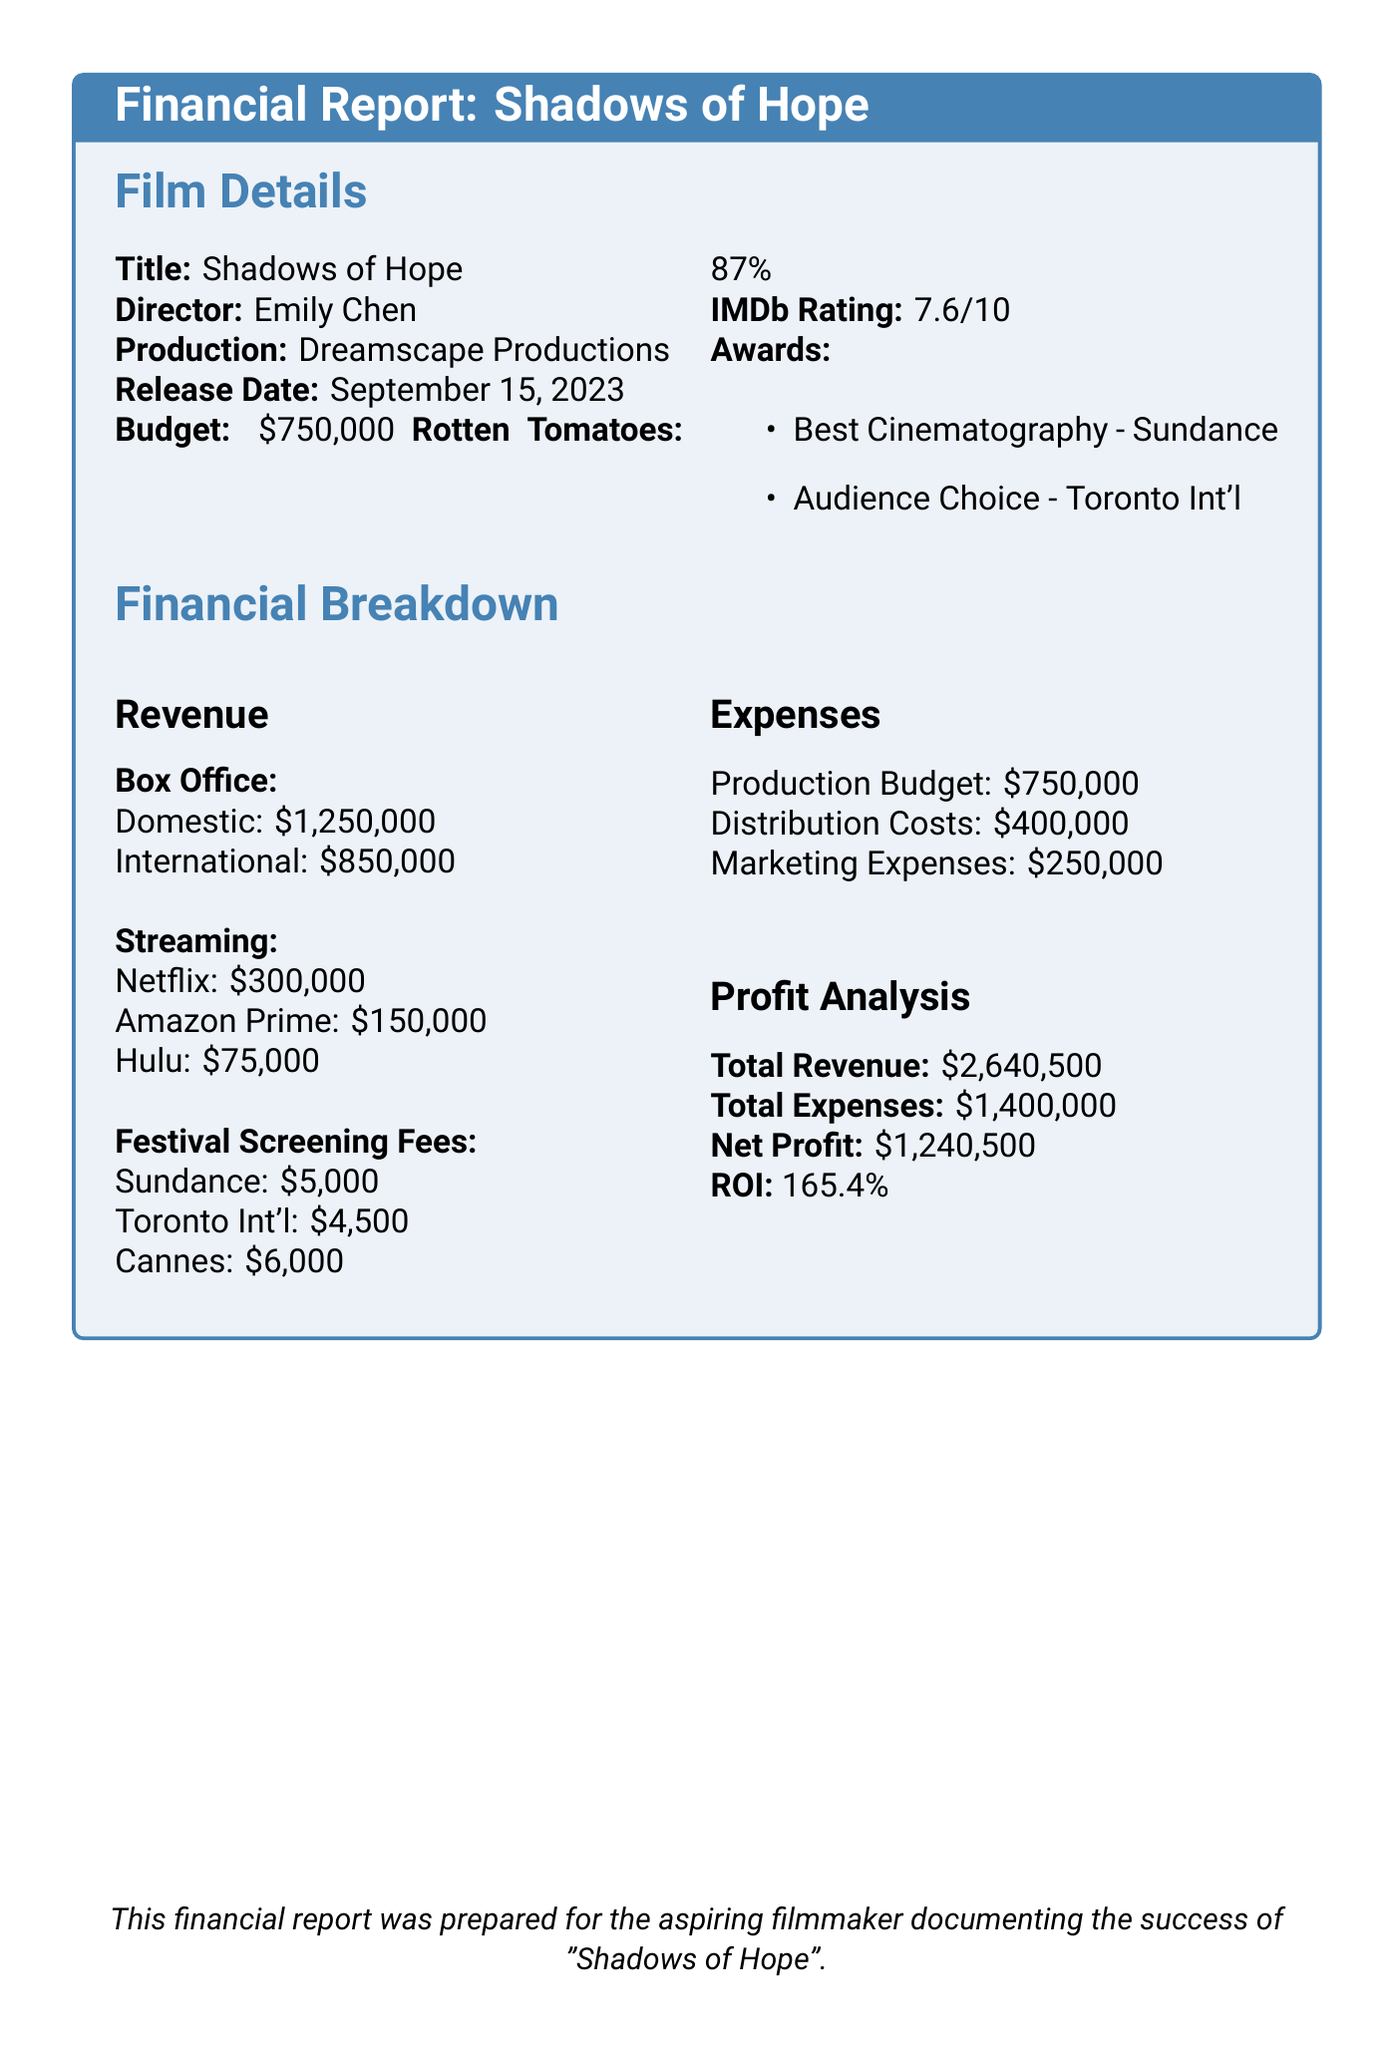What is the film title? The title of the film is indicated at the beginning of the financial report.
Answer: Shadows of Hope Who is the director? The document specifies the director's name under the film details section.
Answer: Emily Chen What is the total box office earnings? The total box office earnings are calculated by adding domestic and international earnings.
Answer: 2100000 What is the streaming revenue from Netflix? The streaming revenue from Netflix is listed under the streaming revenue section of the report.
Answer: 300000 What are the festival screening fees from Sundance? The specific amount for festival screening fees from Sundance is mentioned in the financial breakdown.
Answer: 5000 What is the production budget? The production budget is stated clearly in the film details section of the document.
Answer: 750000 What is the total revenue? The total revenue is presented as the sum of all revenue sources at the end of the financial breakdown.
Answer: 2640500 Which award did the film win at the Sundance Film Festival? The awards section lists the specific achievements of the film, including the awards won.
Answer: Best Cinematography What is the return on investment (ROI)? The ROI is calculated and specified in the financial breakdown section.
Answer: 165.4% 